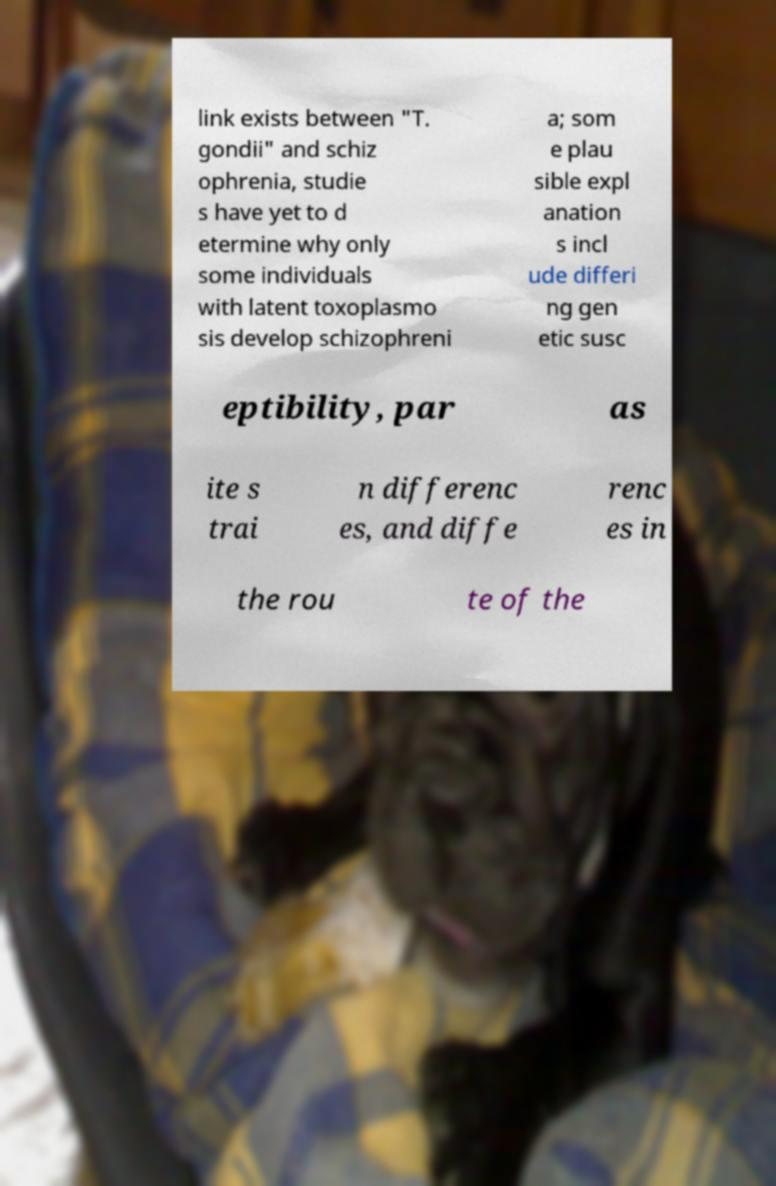Could you assist in decoding the text presented in this image and type it out clearly? link exists between "T. gondii" and schiz ophrenia, studie s have yet to d etermine why only some individuals with latent toxoplasmo sis develop schizophreni a; som e plau sible expl anation s incl ude differi ng gen etic susc eptibility, par as ite s trai n differenc es, and diffe renc es in the rou te of the 